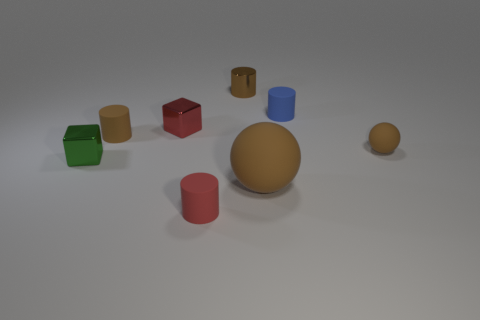Could you guess the source of lighting in this scene? Based on the shadows and highlights on the objects, it seems that the light source is positioned above and slightly to the front right side of the scene. 